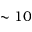Convert formula to latex. <formula><loc_0><loc_0><loc_500><loc_500>\sim 1 0</formula> 